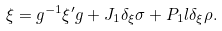<formula> <loc_0><loc_0><loc_500><loc_500>\xi = g ^ { - 1 } \xi ^ { \prime } g + J _ { 1 } \delta _ { \xi } \sigma + P _ { 1 } l \delta _ { \xi } \rho .</formula> 